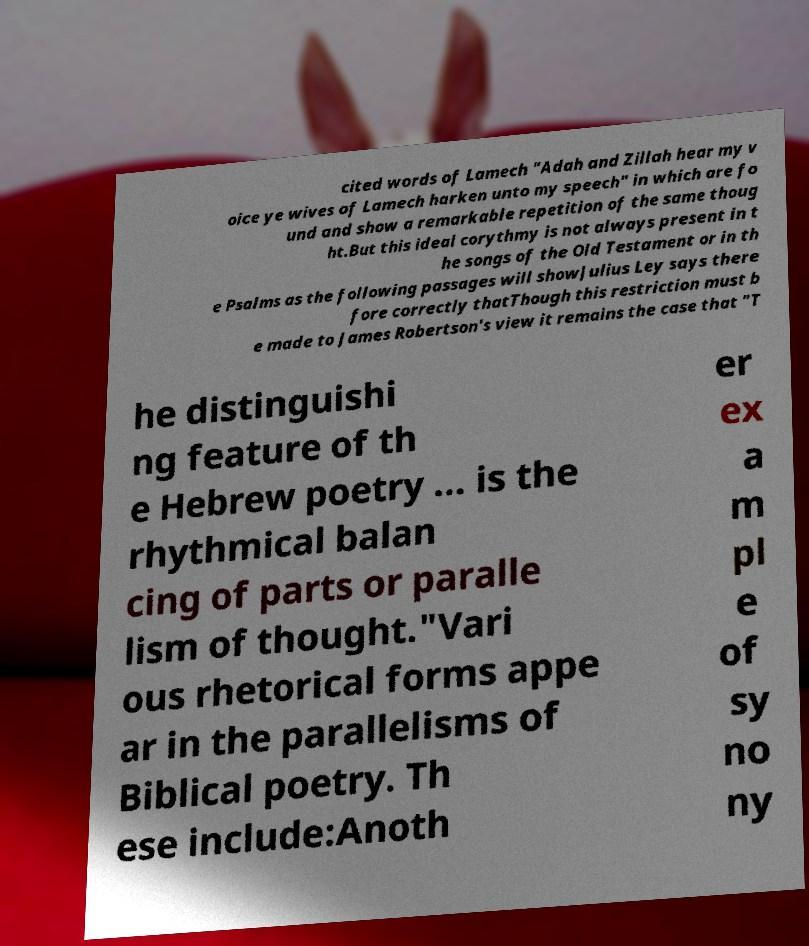Can you accurately transcribe the text from the provided image for me? cited words of Lamech "Adah and Zillah hear my v oice ye wives of Lamech harken unto my speech" in which are fo und and show a remarkable repetition of the same thoug ht.But this ideal corythmy is not always present in t he songs of the Old Testament or in th e Psalms as the following passages will showJulius Ley says there fore correctly thatThough this restriction must b e made to James Robertson's view it remains the case that "T he distinguishi ng feature of th e Hebrew poetry ... is the rhythmical balan cing of parts or paralle lism of thought."Vari ous rhetorical forms appe ar in the parallelisms of Biblical poetry. Th ese include:Anoth er ex a m pl e of sy no ny 